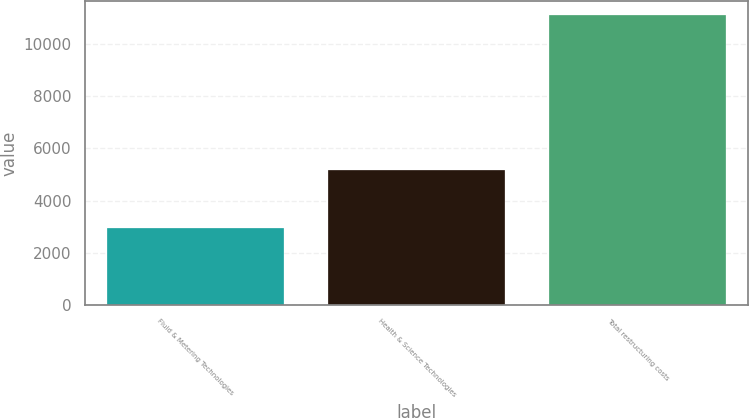Convert chart. <chart><loc_0><loc_0><loc_500><loc_500><bar_chart><fcel>Fluid & Metering Technologies<fcel>Health & Science Technologies<fcel>Total restructuring costs<nl><fcel>2950<fcel>5161<fcel>11095<nl></chart> 